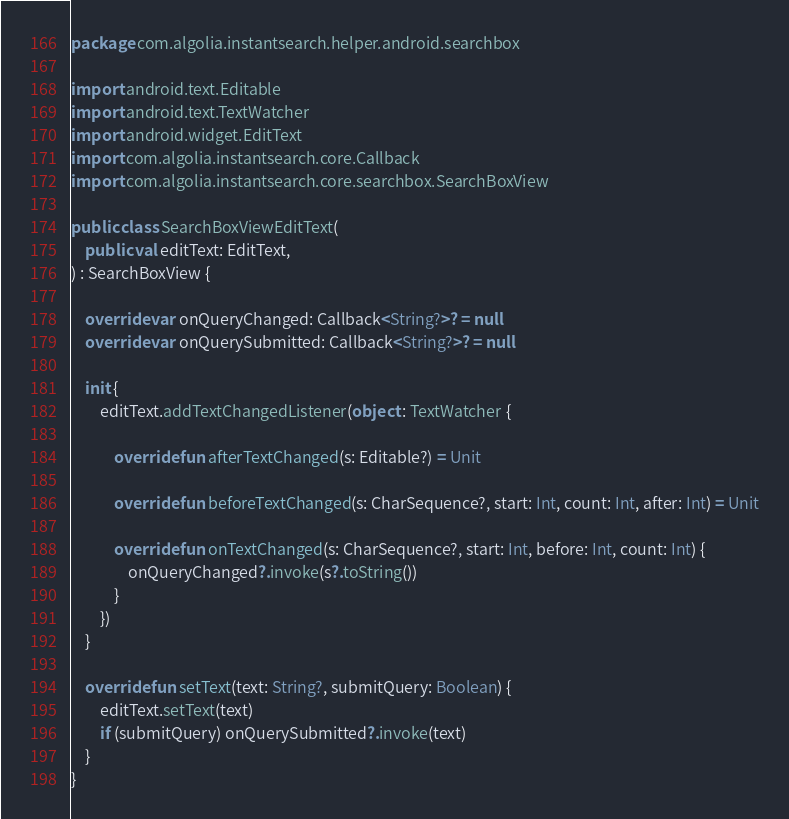<code> <loc_0><loc_0><loc_500><loc_500><_Kotlin_>package com.algolia.instantsearch.helper.android.searchbox

import android.text.Editable
import android.text.TextWatcher
import android.widget.EditText
import com.algolia.instantsearch.core.Callback
import com.algolia.instantsearch.core.searchbox.SearchBoxView

public class SearchBoxViewEditText(
    public val editText: EditText,
) : SearchBoxView {

    override var onQueryChanged: Callback<String?>? = null
    override var onQuerySubmitted: Callback<String?>? = null

    init {
        editText.addTextChangedListener(object : TextWatcher {

            override fun afterTextChanged(s: Editable?) = Unit

            override fun beforeTextChanged(s: CharSequence?, start: Int, count: Int, after: Int) = Unit

            override fun onTextChanged(s: CharSequence?, start: Int, before: Int, count: Int) {
                onQueryChanged?.invoke(s?.toString())
            }
        })
    }

    override fun setText(text: String?, submitQuery: Boolean) {
        editText.setText(text)
        if (submitQuery) onQuerySubmitted?.invoke(text)
    }
}
</code> 